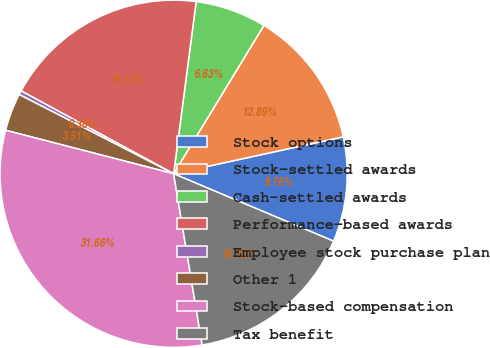<chart> <loc_0><loc_0><loc_500><loc_500><pie_chart><fcel>Stock options<fcel>Stock-settled awards<fcel>Cash-settled awards<fcel>Performance-based awards<fcel>Employee stock purchase plan<fcel>Other 1<fcel>Stock-based compensation<fcel>Tax benefit<nl><fcel>9.76%<fcel>12.89%<fcel>6.63%<fcel>19.15%<fcel>0.38%<fcel>3.51%<fcel>31.66%<fcel>16.02%<nl></chart> 